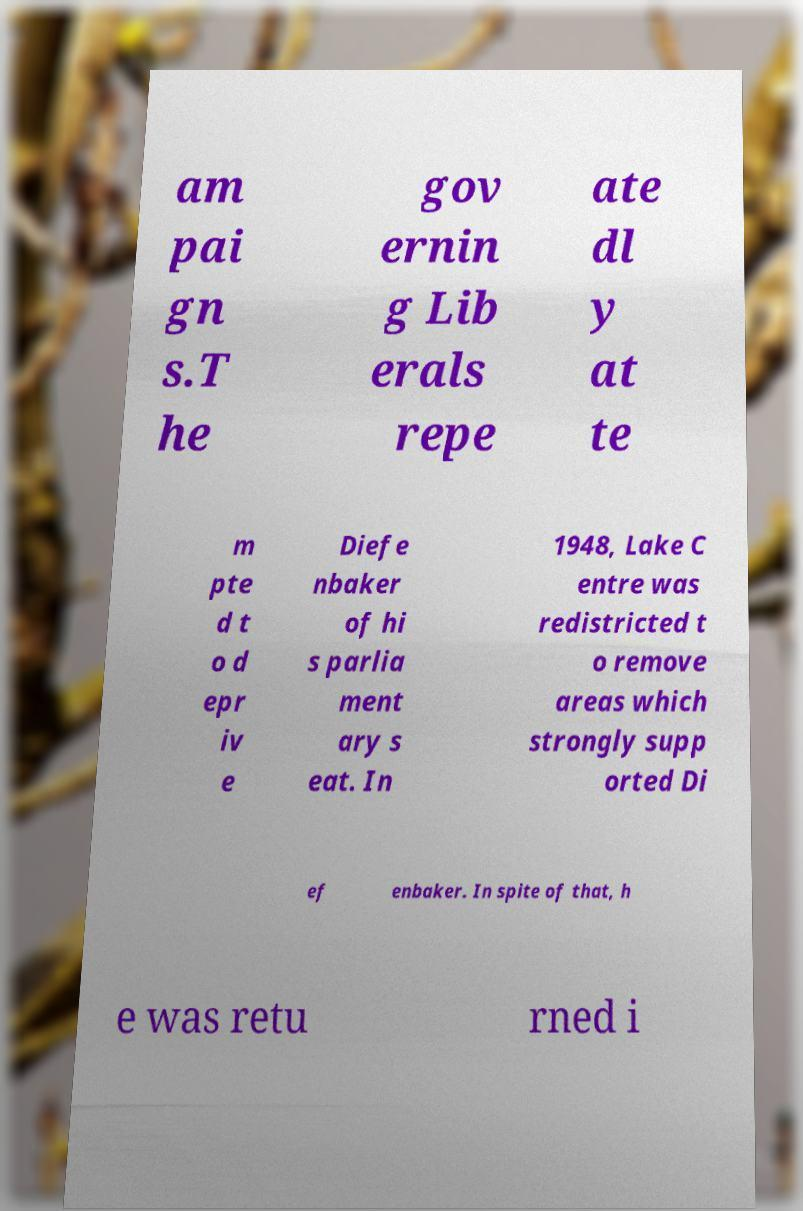Please identify and transcribe the text found in this image. am pai gn s.T he gov ernin g Lib erals repe ate dl y at te m pte d t o d epr iv e Diefe nbaker of hi s parlia ment ary s eat. In 1948, Lake C entre was redistricted t o remove areas which strongly supp orted Di ef enbaker. In spite of that, h e was retu rned i 